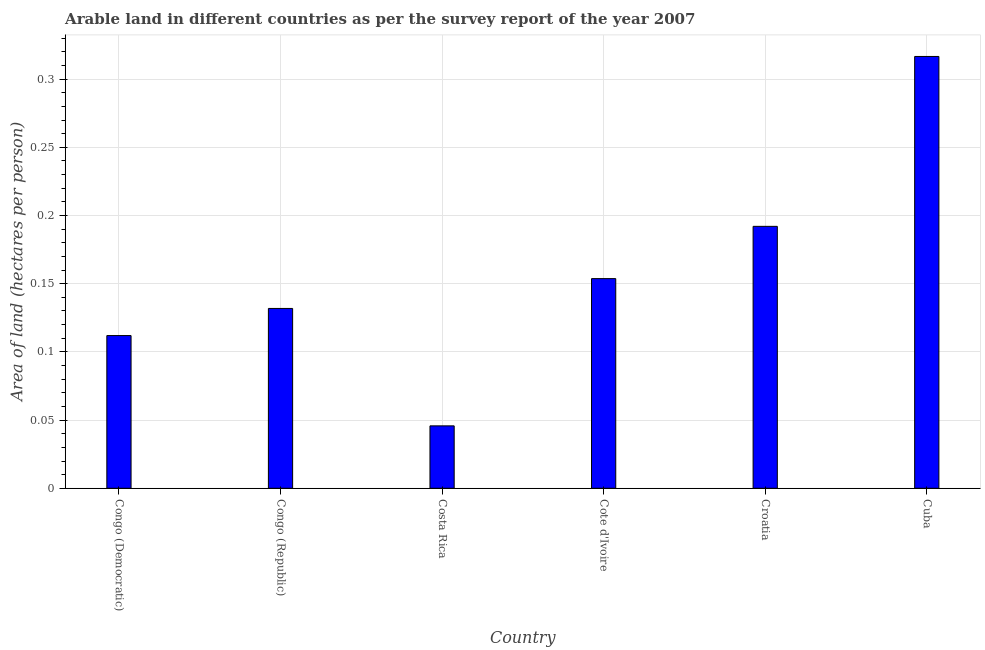Does the graph contain grids?
Your response must be concise. Yes. What is the title of the graph?
Give a very brief answer. Arable land in different countries as per the survey report of the year 2007. What is the label or title of the Y-axis?
Provide a short and direct response. Area of land (hectares per person). What is the area of arable land in Cuba?
Offer a very short reply. 0.32. Across all countries, what is the maximum area of arable land?
Keep it short and to the point. 0.32. Across all countries, what is the minimum area of arable land?
Your answer should be compact. 0.05. In which country was the area of arable land maximum?
Provide a short and direct response. Cuba. What is the sum of the area of arable land?
Offer a terse response. 0.95. What is the difference between the area of arable land in Costa Rica and Cote d'Ivoire?
Your answer should be very brief. -0.11. What is the average area of arable land per country?
Keep it short and to the point. 0.16. What is the median area of arable land?
Make the answer very short. 0.14. In how many countries, is the area of arable land greater than 0.04 hectares per person?
Provide a short and direct response. 6. What is the ratio of the area of arable land in Congo (Democratic) to that in Croatia?
Make the answer very short. 0.58. Is the area of arable land in Costa Rica less than that in Cuba?
Your answer should be compact. Yes. What is the difference between the highest and the second highest area of arable land?
Provide a short and direct response. 0.12. Is the sum of the area of arable land in Congo (Republic) and Costa Rica greater than the maximum area of arable land across all countries?
Give a very brief answer. No. What is the difference between the highest and the lowest area of arable land?
Ensure brevity in your answer.  0.27. Are the values on the major ticks of Y-axis written in scientific E-notation?
Offer a very short reply. No. What is the Area of land (hectares per person) in Congo (Democratic)?
Give a very brief answer. 0.11. What is the Area of land (hectares per person) of Congo (Republic)?
Provide a short and direct response. 0.13. What is the Area of land (hectares per person) in Costa Rica?
Give a very brief answer. 0.05. What is the Area of land (hectares per person) in Cote d'Ivoire?
Your response must be concise. 0.15. What is the Area of land (hectares per person) of Croatia?
Your answer should be very brief. 0.19. What is the Area of land (hectares per person) in Cuba?
Give a very brief answer. 0.32. What is the difference between the Area of land (hectares per person) in Congo (Democratic) and Congo (Republic)?
Your answer should be very brief. -0.02. What is the difference between the Area of land (hectares per person) in Congo (Democratic) and Costa Rica?
Your answer should be compact. 0.07. What is the difference between the Area of land (hectares per person) in Congo (Democratic) and Cote d'Ivoire?
Offer a terse response. -0.04. What is the difference between the Area of land (hectares per person) in Congo (Democratic) and Croatia?
Ensure brevity in your answer.  -0.08. What is the difference between the Area of land (hectares per person) in Congo (Democratic) and Cuba?
Give a very brief answer. -0.2. What is the difference between the Area of land (hectares per person) in Congo (Republic) and Costa Rica?
Your answer should be very brief. 0.09. What is the difference between the Area of land (hectares per person) in Congo (Republic) and Cote d'Ivoire?
Make the answer very short. -0.02. What is the difference between the Area of land (hectares per person) in Congo (Republic) and Croatia?
Give a very brief answer. -0.06. What is the difference between the Area of land (hectares per person) in Congo (Republic) and Cuba?
Provide a succinct answer. -0.18. What is the difference between the Area of land (hectares per person) in Costa Rica and Cote d'Ivoire?
Ensure brevity in your answer.  -0.11. What is the difference between the Area of land (hectares per person) in Costa Rica and Croatia?
Ensure brevity in your answer.  -0.15. What is the difference between the Area of land (hectares per person) in Costa Rica and Cuba?
Keep it short and to the point. -0.27. What is the difference between the Area of land (hectares per person) in Cote d'Ivoire and Croatia?
Your answer should be compact. -0.04. What is the difference between the Area of land (hectares per person) in Cote d'Ivoire and Cuba?
Your answer should be very brief. -0.16. What is the difference between the Area of land (hectares per person) in Croatia and Cuba?
Provide a succinct answer. -0.12. What is the ratio of the Area of land (hectares per person) in Congo (Democratic) to that in Congo (Republic)?
Give a very brief answer. 0.85. What is the ratio of the Area of land (hectares per person) in Congo (Democratic) to that in Costa Rica?
Offer a very short reply. 2.45. What is the ratio of the Area of land (hectares per person) in Congo (Democratic) to that in Cote d'Ivoire?
Your answer should be compact. 0.73. What is the ratio of the Area of land (hectares per person) in Congo (Democratic) to that in Croatia?
Give a very brief answer. 0.58. What is the ratio of the Area of land (hectares per person) in Congo (Democratic) to that in Cuba?
Keep it short and to the point. 0.35. What is the ratio of the Area of land (hectares per person) in Congo (Republic) to that in Costa Rica?
Offer a very short reply. 2.88. What is the ratio of the Area of land (hectares per person) in Congo (Republic) to that in Cote d'Ivoire?
Provide a short and direct response. 0.86. What is the ratio of the Area of land (hectares per person) in Congo (Republic) to that in Croatia?
Your answer should be compact. 0.69. What is the ratio of the Area of land (hectares per person) in Congo (Republic) to that in Cuba?
Keep it short and to the point. 0.42. What is the ratio of the Area of land (hectares per person) in Costa Rica to that in Cote d'Ivoire?
Provide a short and direct response. 0.3. What is the ratio of the Area of land (hectares per person) in Costa Rica to that in Croatia?
Provide a short and direct response. 0.24. What is the ratio of the Area of land (hectares per person) in Costa Rica to that in Cuba?
Ensure brevity in your answer.  0.14. What is the ratio of the Area of land (hectares per person) in Cote d'Ivoire to that in Cuba?
Provide a short and direct response. 0.49. What is the ratio of the Area of land (hectares per person) in Croatia to that in Cuba?
Offer a terse response. 0.61. 